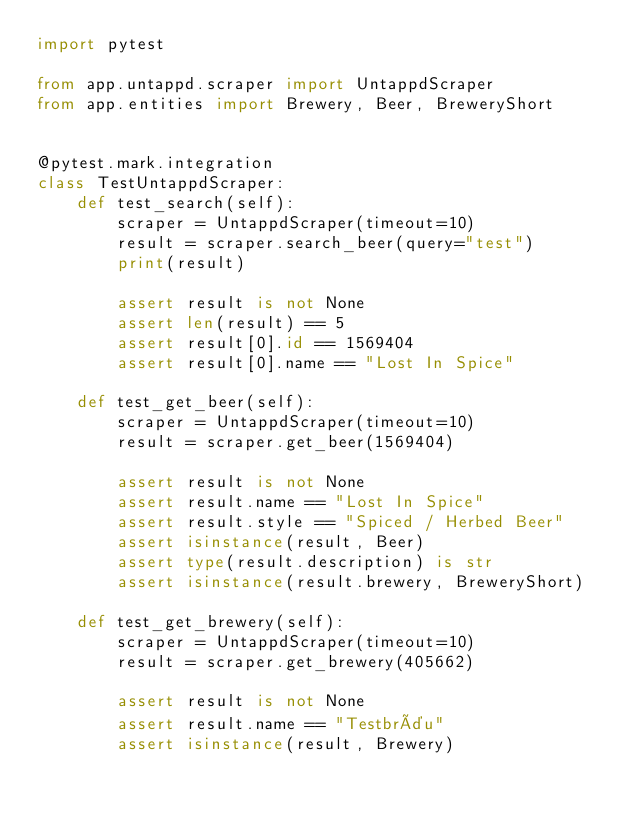<code> <loc_0><loc_0><loc_500><loc_500><_Python_>import pytest

from app.untappd.scraper import UntappdScraper
from app.entities import Brewery, Beer, BreweryShort


@pytest.mark.integration
class TestUntappdScraper:
    def test_search(self):
        scraper = UntappdScraper(timeout=10)
        result = scraper.search_beer(query="test")
        print(result)

        assert result is not None
        assert len(result) == 5
        assert result[0].id == 1569404
        assert result[0].name == "Lost In Spice"

    def test_get_beer(self):
        scraper = UntappdScraper(timeout=10)
        result = scraper.get_beer(1569404)

        assert result is not None
        assert result.name == "Lost In Spice"
        assert result.style == "Spiced / Herbed Beer"
        assert isinstance(result, Beer)
        assert type(result.description) is str
        assert isinstance(result.brewery, BreweryShort)

    def test_get_brewery(self):
        scraper = UntappdScraper(timeout=10)
        result = scraper.get_brewery(405662)

        assert result is not None
        assert result.name == "Testbräu"
        assert isinstance(result, Brewery)
</code> 